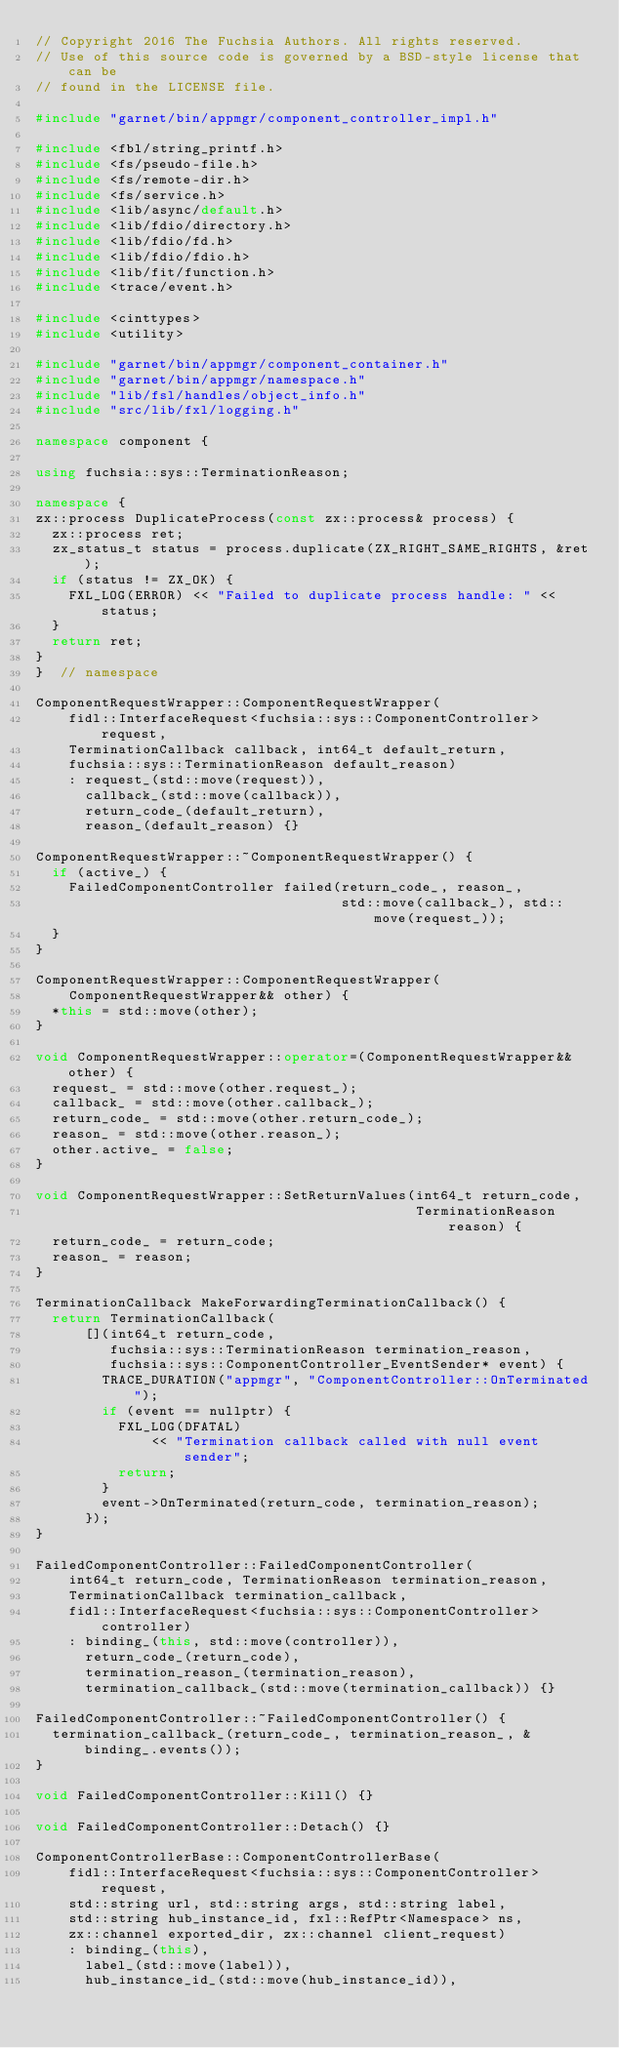Convert code to text. <code><loc_0><loc_0><loc_500><loc_500><_C++_>// Copyright 2016 The Fuchsia Authors. All rights reserved.
// Use of this source code is governed by a BSD-style license that can be
// found in the LICENSE file.

#include "garnet/bin/appmgr/component_controller_impl.h"

#include <fbl/string_printf.h>
#include <fs/pseudo-file.h>
#include <fs/remote-dir.h>
#include <fs/service.h>
#include <lib/async/default.h>
#include <lib/fdio/directory.h>
#include <lib/fdio/fd.h>
#include <lib/fdio/fdio.h>
#include <lib/fit/function.h>
#include <trace/event.h>

#include <cinttypes>
#include <utility>

#include "garnet/bin/appmgr/component_container.h"
#include "garnet/bin/appmgr/namespace.h"
#include "lib/fsl/handles/object_info.h"
#include "src/lib/fxl/logging.h"

namespace component {

using fuchsia::sys::TerminationReason;

namespace {
zx::process DuplicateProcess(const zx::process& process) {
  zx::process ret;
  zx_status_t status = process.duplicate(ZX_RIGHT_SAME_RIGHTS, &ret);
  if (status != ZX_OK) {
    FXL_LOG(ERROR) << "Failed to duplicate process handle: " << status;
  }
  return ret;
}
}  // namespace

ComponentRequestWrapper::ComponentRequestWrapper(
    fidl::InterfaceRequest<fuchsia::sys::ComponentController> request,
    TerminationCallback callback, int64_t default_return,
    fuchsia::sys::TerminationReason default_reason)
    : request_(std::move(request)),
      callback_(std::move(callback)),
      return_code_(default_return),
      reason_(default_reason) {}

ComponentRequestWrapper::~ComponentRequestWrapper() {
  if (active_) {
    FailedComponentController failed(return_code_, reason_,
                                     std::move(callback_), std::move(request_));
  }
}

ComponentRequestWrapper::ComponentRequestWrapper(
    ComponentRequestWrapper&& other) {
  *this = std::move(other);
}

void ComponentRequestWrapper::operator=(ComponentRequestWrapper&& other) {
  request_ = std::move(other.request_);
  callback_ = std::move(other.callback_);
  return_code_ = std::move(other.return_code_);
  reason_ = std::move(other.reason_);
  other.active_ = false;
}

void ComponentRequestWrapper::SetReturnValues(int64_t return_code,
                                              TerminationReason reason) {
  return_code_ = return_code;
  reason_ = reason;
}

TerminationCallback MakeForwardingTerminationCallback() {
  return TerminationCallback(
      [](int64_t return_code,
         fuchsia::sys::TerminationReason termination_reason,
         fuchsia::sys::ComponentController_EventSender* event) {
        TRACE_DURATION("appmgr", "ComponentController::OnTerminated");
        if (event == nullptr) {
          FXL_LOG(DFATAL)
              << "Termination callback called with null event sender";
          return;
        }
        event->OnTerminated(return_code, termination_reason);
      });
}

FailedComponentController::FailedComponentController(
    int64_t return_code, TerminationReason termination_reason,
    TerminationCallback termination_callback,
    fidl::InterfaceRequest<fuchsia::sys::ComponentController> controller)
    : binding_(this, std::move(controller)),
      return_code_(return_code),
      termination_reason_(termination_reason),
      termination_callback_(std::move(termination_callback)) {}

FailedComponentController::~FailedComponentController() {
  termination_callback_(return_code_, termination_reason_, &binding_.events());
}

void FailedComponentController::Kill() {}

void FailedComponentController::Detach() {}

ComponentControllerBase::ComponentControllerBase(
    fidl::InterfaceRequest<fuchsia::sys::ComponentController> request,
    std::string url, std::string args, std::string label,
    std::string hub_instance_id, fxl::RefPtr<Namespace> ns,
    zx::channel exported_dir, zx::channel client_request)
    : binding_(this),
      label_(std::move(label)),
      hub_instance_id_(std::move(hub_instance_id)),</code> 